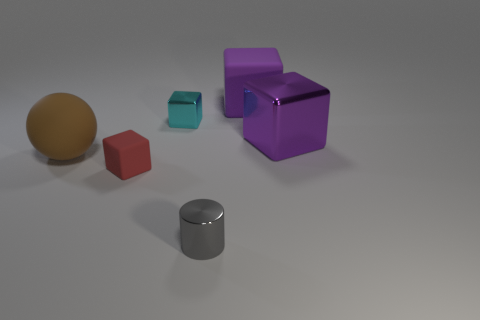Add 1 small gray objects. How many objects exist? 7 Subtract all green cubes. Subtract all blue balls. How many cubes are left? 4 Subtract all cylinders. How many objects are left? 5 Subtract 1 gray cylinders. How many objects are left? 5 Subtract all tiny cyan blocks. Subtract all large yellow metal blocks. How many objects are left? 5 Add 4 large objects. How many large objects are left? 7 Add 1 tiny rubber things. How many tiny rubber things exist? 2 